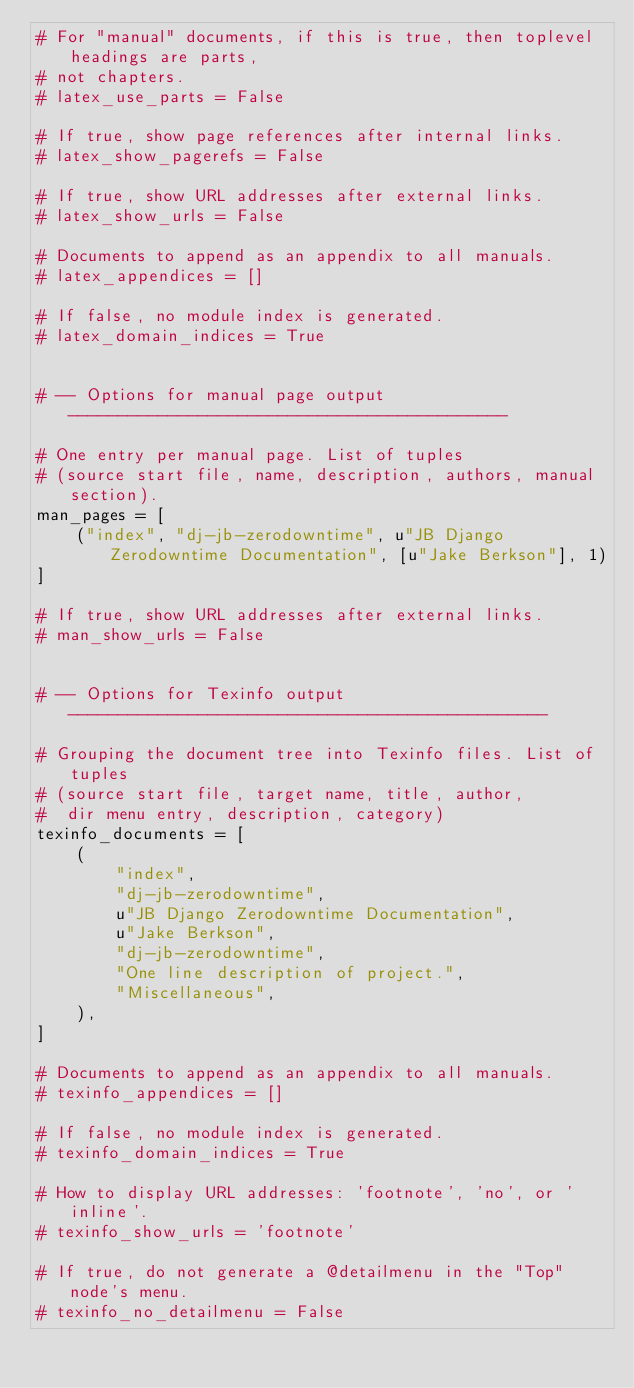Convert code to text. <code><loc_0><loc_0><loc_500><loc_500><_Python_># For "manual" documents, if this is true, then toplevel headings are parts,
# not chapters.
# latex_use_parts = False

# If true, show page references after internal links.
# latex_show_pagerefs = False

# If true, show URL addresses after external links.
# latex_show_urls = False

# Documents to append as an appendix to all manuals.
# latex_appendices = []

# If false, no module index is generated.
# latex_domain_indices = True


# -- Options for manual page output --------------------------------------------

# One entry per manual page. List of tuples
# (source start file, name, description, authors, manual section).
man_pages = [
    ("index", "dj-jb-zerodowntime", u"JB Django Zerodowntime Documentation", [u"Jake Berkson"], 1)
]

# If true, show URL addresses after external links.
# man_show_urls = False


# -- Options for Texinfo output ------------------------------------------------

# Grouping the document tree into Texinfo files. List of tuples
# (source start file, target name, title, author,
#  dir menu entry, description, category)
texinfo_documents = [
    (
        "index",
        "dj-jb-zerodowntime",
        u"JB Django Zerodowntime Documentation",
        u"Jake Berkson",
        "dj-jb-zerodowntime",
        "One line description of project.",
        "Miscellaneous",
    ),
]

# Documents to append as an appendix to all manuals.
# texinfo_appendices = []

# If false, no module index is generated.
# texinfo_domain_indices = True

# How to display URL addresses: 'footnote', 'no', or 'inline'.
# texinfo_show_urls = 'footnote'

# If true, do not generate a @detailmenu in the "Top" node's menu.
# texinfo_no_detailmenu = False
</code> 